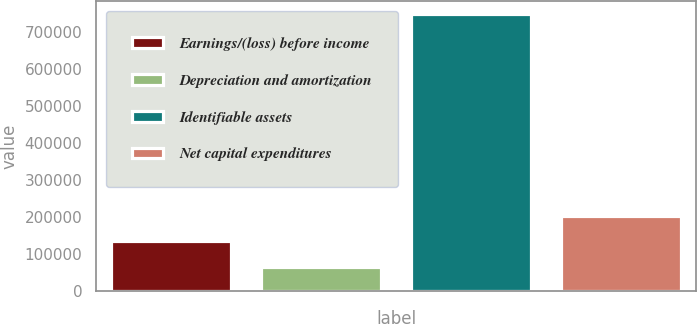<chart> <loc_0><loc_0><loc_500><loc_500><bar_chart><fcel>Earnings/(loss) before income<fcel>Depreciation and amortization<fcel>Identifiable assets<fcel>Net capital expenditures<nl><fcel>134760<fcel>66800<fcel>746398<fcel>202720<nl></chart> 